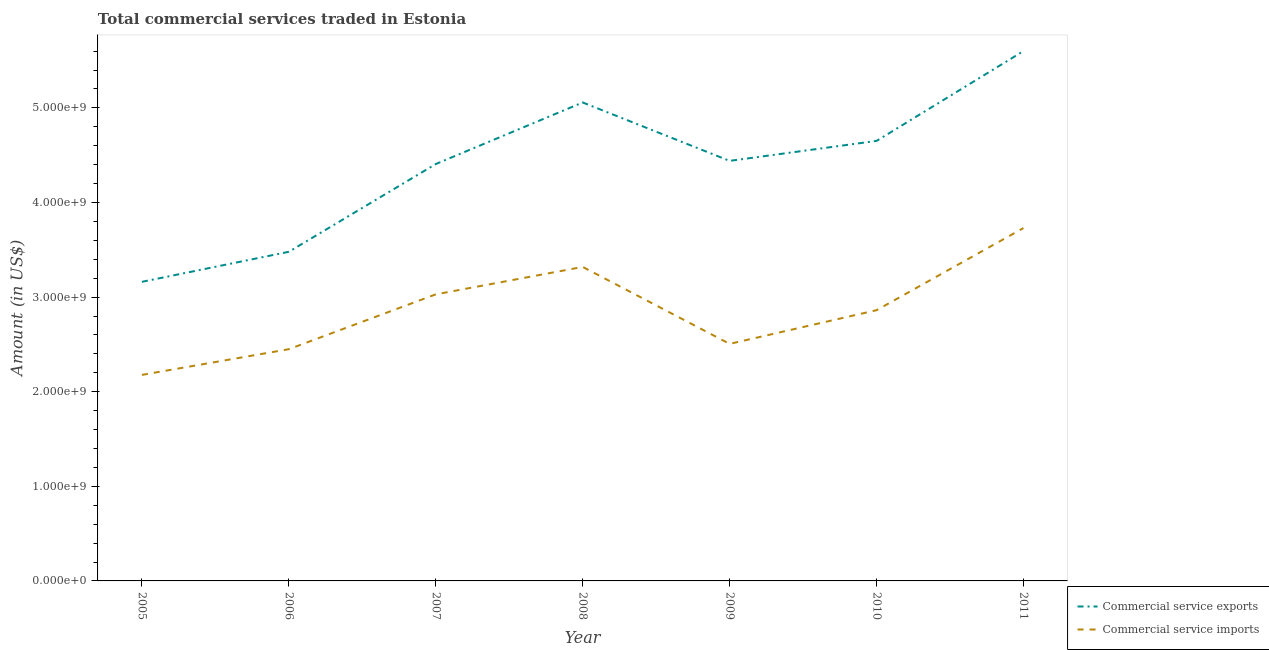How many different coloured lines are there?
Keep it short and to the point. 2. What is the amount of commercial service exports in 2008?
Your answer should be very brief. 5.06e+09. Across all years, what is the maximum amount of commercial service imports?
Offer a very short reply. 3.73e+09. Across all years, what is the minimum amount of commercial service exports?
Your answer should be very brief. 3.16e+09. In which year was the amount of commercial service exports minimum?
Offer a terse response. 2005. What is the total amount of commercial service imports in the graph?
Offer a terse response. 2.01e+1. What is the difference between the amount of commercial service exports in 2007 and that in 2009?
Offer a terse response. -3.35e+07. What is the difference between the amount of commercial service imports in 2007 and the amount of commercial service exports in 2011?
Make the answer very short. -2.57e+09. What is the average amount of commercial service exports per year?
Offer a very short reply. 4.40e+09. In the year 2010, what is the difference between the amount of commercial service imports and amount of commercial service exports?
Your answer should be very brief. -1.79e+09. What is the ratio of the amount of commercial service imports in 2005 to that in 2010?
Ensure brevity in your answer.  0.76. Is the amount of commercial service exports in 2006 less than that in 2007?
Give a very brief answer. Yes. Is the difference between the amount of commercial service imports in 2007 and 2009 greater than the difference between the amount of commercial service exports in 2007 and 2009?
Your answer should be compact. Yes. What is the difference between the highest and the second highest amount of commercial service imports?
Make the answer very short. 4.11e+08. What is the difference between the highest and the lowest amount of commercial service exports?
Ensure brevity in your answer.  2.44e+09. Is the sum of the amount of commercial service exports in 2009 and 2010 greater than the maximum amount of commercial service imports across all years?
Provide a short and direct response. Yes. Is the amount of commercial service imports strictly less than the amount of commercial service exports over the years?
Your answer should be compact. Yes. Are the values on the major ticks of Y-axis written in scientific E-notation?
Ensure brevity in your answer.  Yes. Does the graph contain any zero values?
Your answer should be compact. No. Where does the legend appear in the graph?
Give a very brief answer. Bottom right. What is the title of the graph?
Ensure brevity in your answer.  Total commercial services traded in Estonia. What is the Amount (in US$) of Commercial service exports in 2005?
Offer a very short reply. 3.16e+09. What is the Amount (in US$) of Commercial service imports in 2005?
Your answer should be very brief. 2.18e+09. What is the Amount (in US$) of Commercial service exports in 2006?
Your answer should be compact. 3.48e+09. What is the Amount (in US$) in Commercial service imports in 2006?
Make the answer very short. 2.45e+09. What is the Amount (in US$) of Commercial service exports in 2007?
Offer a terse response. 4.41e+09. What is the Amount (in US$) in Commercial service imports in 2007?
Make the answer very short. 3.03e+09. What is the Amount (in US$) of Commercial service exports in 2008?
Offer a terse response. 5.06e+09. What is the Amount (in US$) in Commercial service imports in 2008?
Offer a very short reply. 3.32e+09. What is the Amount (in US$) in Commercial service exports in 2009?
Provide a succinct answer. 4.44e+09. What is the Amount (in US$) in Commercial service imports in 2009?
Provide a succinct answer. 2.51e+09. What is the Amount (in US$) in Commercial service exports in 2010?
Ensure brevity in your answer.  4.65e+09. What is the Amount (in US$) of Commercial service imports in 2010?
Provide a succinct answer. 2.86e+09. What is the Amount (in US$) of Commercial service exports in 2011?
Make the answer very short. 5.60e+09. What is the Amount (in US$) of Commercial service imports in 2011?
Your answer should be very brief. 3.73e+09. Across all years, what is the maximum Amount (in US$) in Commercial service exports?
Make the answer very short. 5.60e+09. Across all years, what is the maximum Amount (in US$) of Commercial service imports?
Your answer should be very brief. 3.73e+09. Across all years, what is the minimum Amount (in US$) in Commercial service exports?
Give a very brief answer. 3.16e+09. Across all years, what is the minimum Amount (in US$) in Commercial service imports?
Your answer should be very brief. 2.18e+09. What is the total Amount (in US$) of Commercial service exports in the graph?
Provide a short and direct response. 3.08e+1. What is the total Amount (in US$) of Commercial service imports in the graph?
Your response must be concise. 2.01e+1. What is the difference between the Amount (in US$) in Commercial service exports in 2005 and that in 2006?
Your answer should be compact. -3.18e+08. What is the difference between the Amount (in US$) in Commercial service imports in 2005 and that in 2006?
Keep it short and to the point. -2.72e+08. What is the difference between the Amount (in US$) in Commercial service exports in 2005 and that in 2007?
Provide a succinct answer. -1.25e+09. What is the difference between the Amount (in US$) of Commercial service imports in 2005 and that in 2007?
Your answer should be compact. -8.51e+08. What is the difference between the Amount (in US$) in Commercial service exports in 2005 and that in 2008?
Keep it short and to the point. -1.90e+09. What is the difference between the Amount (in US$) of Commercial service imports in 2005 and that in 2008?
Offer a very short reply. -1.14e+09. What is the difference between the Amount (in US$) in Commercial service exports in 2005 and that in 2009?
Give a very brief answer. -1.28e+09. What is the difference between the Amount (in US$) in Commercial service imports in 2005 and that in 2009?
Offer a very short reply. -3.28e+08. What is the difference between the Amount (in US$) in Commercial service exports in 2005 and that in 2010?
Ensure brevity in your answer.  -1.49e+09. What is the difference between the Amount (in US$) in Commercial service imports in 2005 and that in 2010?
Your response must be concise. -6.84e+08. What is the difference between the Amount (in US$) of Commercial service exports in 2005 and that in 2011?
Your answer should be very brief. -2.44e+09. What is the difference between the Amount (in US$) in Commercial service imports in 2005 and that in 2011?
Offer a terse response. -1.55e+09. What is the difference between the Amount (in US$) of Commercial service exports in 2006 and that in 2007?
Keep it short and to the point. -9.27e+08. What is the difference between the Amount (in US$) of Commercial service imports in 2006 and that in 2007?
Your answer should be very brief. -5.80e+08. What is the difference between the Amount (in US$) in Commercial service exports in 2006 and that in 2008?
Your answer should be compact. -1.58e+09. What is the difference between the Amount (in US$) in Commercial service imports in 2006 and that in 2008?
Offer a very short reply. -8.69e+08. What is the difference between the Amount (in US$) of Commercial service exports in 2006 and that in 2009?
Make the answer very short. -9.61e+08. What is the difference between the Amount (in US$) in Commercial service imports in 2006 and that in 2009?
Give a very brief answer. -5.63e+07. What is the difference between the Amount (in US$) of Commercial service exports in 2006 and that in 2010?
Your answer should be very brief. -1.17e+09. What is the difference between the Amount (in US$) of Commercial service imports in 2006 and that in 2010?
Provide a succinct answer. -4.12e+08. What is the difference between the Amount (in US$) of Commercial service exports in 2006 and that in 2011?
Offer a very short reply. -2.12e+09. What is the difference between the Amount (in US$) of Commercial service imports in 2006 and that in 2011?
Give a very brief answer. -1.28e+09. What is the difference between the Amount (in US$) of Commercial service exports in 2007 and that in 2008?
Offer a terse response. -6.51e+08. What is the difference between the Amount (in US$) of Commercial service imports in 2007 and that in 2008?
Your answer should be very brief. -2.90e+08. What is the difference between the Amount (in US$) of Commercial service exports in 2007 and that in 2009?
Your answer should be compact. -3.35e+07. What is the difference between the Amount (in US$) of Commercial service imports in 2007 and that in 2009?
Keep it short and to the point. 5.23e+08. What is the difference between the Amount (in US$) of Commercial service exports in 2007 and that in 2010?
Keep it short and to the point. -2.45e+08. What is the difference between the Amount (in US$) in Commercial service imports in 2007 and that in 2010?
Your answer should be compact. 1.67e+08. What is the difference between the Amount (in US$) of Commercial service exports in 2007 and that in 2011?
Make the answer very short. -1.19e+09. What is the difference between the Amount (in US$) in Commercial service imports in 2007 and that in 2011?
Keep it short and to the point. -7.01e+08. What is the difference between the Amount (in US$) in Commercial service exports in 2008 and that in 2009?
Keep it short and to the point. 6.17e+08. What is the difference between the Amount (in US$) in Commercial service imports in 2008 and that in 2009?
Provide a succinct answer. 8.13e+08. What is the difference between the Amount (in US$) in Commercial service exports in 2008 and that in 2010?
Provide a short and direct response. 4.06e+08. What is the difference between the Amount (in US$) of Commercial service imports in 2008 and that in 2010?
Ensure brevity in your answer.  4.57e+08. What is the difference between the Amount (in US$) in Commercial service exports in 2008 and that in 2011?
Your answer should be very brief. -5.43e+08. What is the difference between the Amount (in US$) of Commercial service imports in 2008 and that in 2011?
Give a very brief answer. -4.11e+08. What is the difference between the Amount (in US$) of Commercial service exports in 2009 and that in 2010?
Ensure brevity in your answer.  -2.11e+08. What is the difference between the Amount (in US$) in Commercial service imports in 2009 and that in 2010?
Ensure brevity in your answer.  -3.56e+08. What is the difference between the Amount (in US$) of Commercial service exports in 2009 and that in 2011?
Give a very brief answer. -1.16e+09. What is the difference between the Amount (in US$) of Commercial service imports in 2009 and that in 2011?
Your answer should be compact. -1.22e+09. What is the difference between the Amount (in US$) of Commercial service exports in 2010 and that in 2011?
Offer a very short reply. -9.50e+08. What is the difference between the Amount (in US$) in Commercial service imports in 2010 and that in 2011?
Ensure brevity in your answer.  -8.68e+08. What is the difference between the Amount (in US$) of Commercial service exports in 2005 and the Amount (in US$) of Commercial service imports in 2006?
Offer a terse response. 7.12e+08. What is the difference between the Amount (in US$) in Commercial service exports in 2005 and the Amount (in US$) in Commercial service imports in 2007?
Offer a very short reply. 1.32e+08. What is the difference between the Amount (in US$) of Commercial service exports in 2005 and the Amount (in US$) of Commercial service imports in 2008?
Offer a terse response. -1.57e+08. What is the difference between the Amount (in US$) in Commercial service exports in 2005 and the Amount (in US$) in Commercial service imports in 2009?
Your response must be concise. 6.56e+08. What is the difference between the Amount (in US$) of Commercial service exports in 2005 and the Amount (in US$) of Commercial service imports in 2010?
Offer a very short reply. 3.00e+08. What is the difference between the Amount (in US$) in Commercial service exports in 2005 and the Amount (in US$) in Commercial service imports in 2011?
Provide a succinct answer. -5.68e+08. What is the difference between the Amount (in US$) in Commercial service exports in 2006 and the Amount (in US$) in Commercial service imports in 2007?
Provide a short and direct response. 4.50e+08. What is the difference between the Amount (in US$) of Commercial service exports in 2006 and the Amount (in US$) of Commercial service imports in 2008?
Your answer should be very brief. 1.60e+08. What is the difference between the Amount (in US$) in Commercial service exports in 2006 and the Amount (in US$) in Commercial service imports in 2009?
Your answer should be compact. 9.73e+08. What is the difference between the Amount (in US$) of Commercial service exports in 2006 and the Amount (in US$) of Commercial service imports in 2010?
Ensure brevity in your answer.  6.17e+08. What is the difference between the Amount (in US$) of Commercial service exports in 2006 and the Amount (in US$) of Commercial service imports in 2011?
Ensure brevity in your answer.  -2.51e+08. What is the difference between the Amount (in US$) in Commercial service exports in 2007 and the Amount (in US$) in Commercial service imports in 2008?
Your answer should be compact. 1.09e+09. What is the difference between the Amount (in US$) in Commercial service exports in 2007 and the Amount (in US$) in Commercial service imports in 2009?
Make the answer very short. 1.90e+09. What is the difference between the Amount (in US$) of Commercial service exports in 2007 and the Amount (in US$) of Commercial service imports in 2010?
Make the answer very short. 1.54e+09. What is the difference between the Amount (in US$) of Commercial service exports in 2007 and the Amount (in US$) of Commercial service imports in 2011?
Offer a terse response. 6.77e+08. What is the difference between the Amount (in US$) in Commercial service exports in 2008 and the Amount (in US$) in Commercial service imports in 2009?
Your answer should be compact. 2.55e+09. What is the difference between the Amount (in US$) of Commercial service exports in 2008 and the Amount (in US$) of Commercial service imports in 2010?
Offer a terse response. 2.20e+09. What is the difference between the Amount (in US$) in Commercial service exports in 2008 and the Amount (in US$) in Commercial service imports in 2011?
Your answer should be compact. 1.33e+09. What is the difference between the Amount (in US$) in Commercial service exports in 2009 and the Amount (in US$) in Commercial service imports in 2010?
Keep it short and to the point. 1.58e+09. What is the difference between the Amount (in US$) in Commercial service exports in 2009 and the Amount (in US$) in Commercial service imports in 2011?
Give a very brief answer. 7.10e+08. What is the difference between the Amount (in US$) of Commercial service exports in 2010 and the Amount (in US$) of Commercial service imports in 2011?
Offer a terse response. 9.21e+08. What is the average Amount (in US$) in Commercial service exports per year?
Ensure brevity in your answer.  4.40e+09. What is the average Amount (in US$) in Commercial service imports per year?
Offer a very short reply. 2.87e+09. In the year 2005, what is the difference between the Amount (in US$) of Commercial service exports and Amount (in US$) of Commercial service imports?
Your answer should be very brief. 9.84e+08. In the year 2006, what is the difference between the Amount (in US$) of Commercial service exports and Amount (in US$) of Commercial service imports?
Provide a short and direct response. 1.03e+09. In the year 2007, what is the difference between the Amount (in US$) in Commercial service exports and Amount (in US$) in Commercial service imports?
Give a very brief answer. 1.38e+09. In the year 2008, what is the difference between the Amount (in US$) of Commercial service exports and Amount (in US$) of Commercial service imports?
Provide a succinct answer. 1.74e+09. In the year 2009, what is the difference between the Amount (in US$) in Commercial service exports and Amount (in US$) in Commercial service imports?
Offer a very short reply. 1.93e+09. In the year 2010, what is the difference between the Amount (in US$) in Commercial service exports and Amount (in US$) in Commercial service imports?
Ensure brevity in your answer.  1.79e+09. In the year 2011, what is the difference between the Amount (in US$) of Commercial service exports and Amount (in US$) of Commercial service imports?
Offer a very short reply. 1.87e+09. What is the ratio of the Amount (in US$) in Commercial service exports in 2005 to that in 2006?
Offer a very short reply. 0.91. What is the ratio of the Amount (in US$) in Commercial service imports in 2005 to that in 2006?
Provide a succinct answer. 0.89. What is the ratio of the Amount (in US$) of Commercial service exports in 2005 to that in 2007?
Make the answer very short. 0.72. What is the ratio of the Amount (in US$) in Commercial service imports in 2005 to that in 2007?
Provide a succinct answer. 0.72. What is the ratio of the Amount (in US$) of Commercial service exports in 2005 to that in 2008?
Provide a succinct answer. 0.63. What is the ratio of the Amount (in US$) in Commercial service imports in 2005 to that in 2008?
Your answer should be compact. 0.66. What is the ratio of the Amount (in US$) of Commercial service exports in 2005 to that in 2009?
Make the answer very short. 0.71. What is the ratio of the Amount (in US$) in Commercial service imports in 2005 to that in 2009?
Your answer should be very brief. 0.87. What is the ratio of the Amount (in US$) of Commercial service exports in 2005 to that in 2010?
Your answer should be compact. 0.68. What is the ratio of the Amount (in US$) of Commercial service imports in 2005 to that in 2010?
Your answer should be very brief. 0.76. What is the ratio of the Amount (in US$) of Commercial service exports in 2005 to that in 2011?
Offer a very short reply. 0.56. What is the ratio of the Amount (in US$) of Commercial service imports in 2005 to that in 2011?
Provide a short and direct response. 0.58. What is the ratio of the Amount (in US$) in Commercial service exports in 2006 to that in 2007?
Your response must be concise. 0.79. What is the ratio of the Amount (in US$) of Commercial service imports in 2006 to that in 2007?
Offer a terse response. 0.81. What is the ratio of the Amount (in US$) in Commercial service exports in 2006 to that in 2008?
Your response must be concise. 0.69. What is the ratio of the Amount (in US$) in Commercial service imports in 2006 to that in 2008?
Give a very brief answer. 0.74. What is the ratio of the Amount (in US$) of Commercial service exports in 2006 to that in 2009?
Offer a very short reply. 0.78. What is the ratio of the Amount (in US$) of Commercial service imports in 2006 to that in 2009?
Your response must be concise. 0.98. What is the ratio of the Amount (in US$) of Commercial service exports in 2006 to that in 2010?
Your answer should be very brief. 0.75. What is the ratio of the Amount (in US$) in Commercial service imports in 2006 to that in 2010?
Keep it short and to the point. 0.86. What is the ratio of the Amount (in US$) of Commercial service exports in 2006 to that in 2011?
Your answer should be compact. 0.62. What is the ratio of the Amount (in US$) in Commercial service imports in 2006 to that in 2011?
Provide a short and direct response. 0.66. What is the ratio of the Amount (in US$) of Commercial service exports in 2007 to that in 2008?
Make the answer very short. 0.87. What is the ratio of the Amount (in US$) of Commercial service imports in 2007 to that in 2008?
Give a very brief answer. 0.91. What is the ratio of the Amount (in US$) in Commercial service imports in 2007 to that in 2009?
Keep it short and to the point. 1.21. What is the ratio of the Amount (in US$) in Commercial service imports in 2007 to that in 2010?
Provide a succinct answer. 1.06. What is the ratio of the Amount (in US$) of Commercial service exports in 2007 to that in 2011?
Your answer should be very brief. 0.79. What is the ratio of the Amount (in US$) in Commercial service imports in 2007 to that in 2011?
Provide a succinct answer. 0.81. What is the ratio of the Amount (in US$) in Commercial service exports in 2008 to that in 2009?
Keep it short and to the point. 1.14. What is the ratio of the Amount (in US$) of Commercial service imports in 2008 to that in 2009?
Your answer should be very brief. 1.32. What is the ratio of the Amount (in US$) of Commercial service exports in 2008 to that in 2010?
Keep it short and to the point. 1.09. What is the ratio of the Amount (in US$) of Commercial service imports in 2008 to that in 2010?
Make the answer very short. 1.16. What is the ratio of the Amount (in US$) of Commercial service exports in 2008 to that in 2011?
Ensure brevity in your answer.  0.9. What is the ratio of the Amount (in US$) of Commercial service imports in 2008 to that in 2011?
Give a very brief answer. 0.89. What is the ratio of the Amount (in US$) in Commercial service exports in 2009 to that in 2010?
Provide a short and direct response. 0.95. What is the ratio of the Amount (in US$) in Commercial service imports in 2009 to that in 2010?
Keep it short and to the point. 0.88. What is the ratio of the Amount (in US$) of Commercial service exports in 2009 to that in 2011?
Provide a succinct answer. 0.79. What is the ratio of the Amount (in US$) in Commercial service imports in 2009 to that in 2011?
Your answer should be very brief. 0.67. What is the ratio of the Amount (in US$) of Commercial service exports in 2010 to that in 2011?
Your response must be concise. 0.83. What is the ratio of the Amount (in US$) in Commercial service imports in 2010 to that in 2011?
Provide a short and direct response. 0.77. What is the difference between the highest and the second highest Amount (in US$) in Commercial service exports?
Give a very brief answer. 5.43e+08. What is the difference between the highest and the second highest Amount (in US$) of Commercial service imports?
Your answer should be compact. 4.11e+08. What is the difference between the highest and the lowest Amount (in US$) of Commercial service exports?
Your answer should be compact. 2.44e+09. What is the difference between the highest and the lowest Amount (in US$) in Commercial service imports?
Your response must be concise. 1.55e+09. 